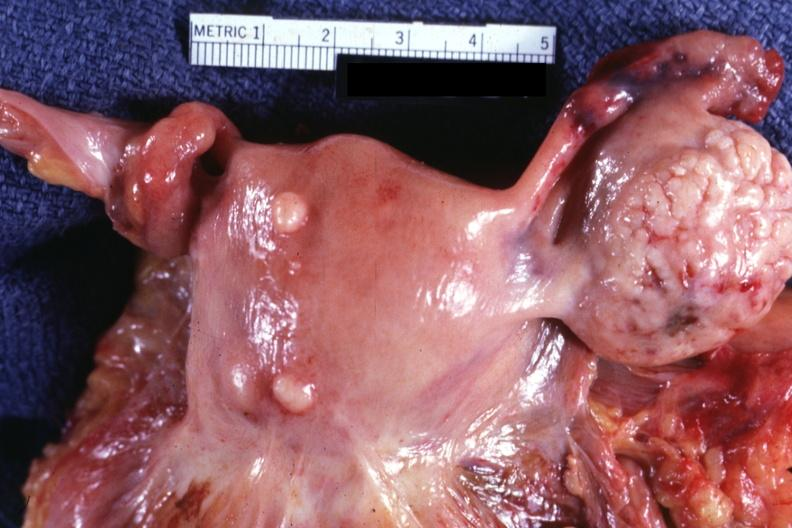s female reproductive present?
Answer the question using a single word or phrase. Yes 